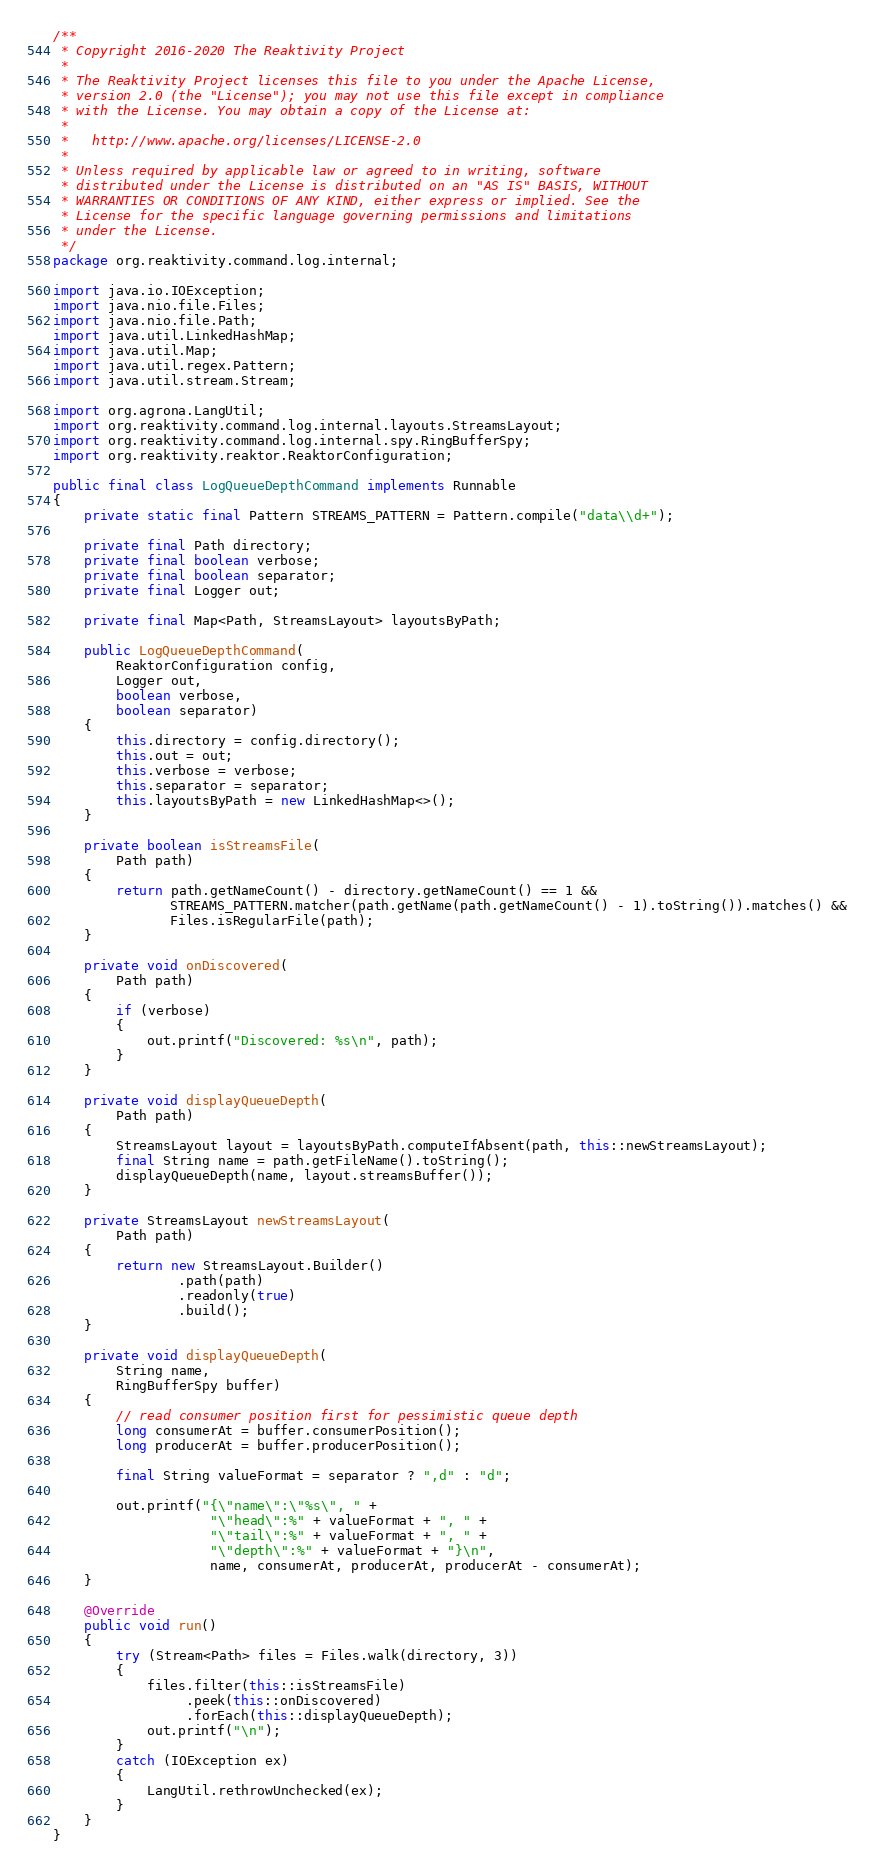Convert code to text. <code><loc_0><loc_0><loc_500><loc_500><_Java_>/**
 * Copyright 2016-2020 The Reaktivity Project
 *
 * The Reaktivity Project licenses this file to you under the Apache License,
 * version 2.0 (the "License"); you may not use this file except in compliance
 * with the License. You may obtain a copy of the License at:
 *
 *   http://www.apache.org/licenses/LICENSE-2.0
 *
 * Unless required by applicable law or agreed to in writing, software
 * distributed under the License is distributed on an "AS IS" BASIS, WITHOUT
 * WARRANTIES OR CONDITIONS OF ANY KIND, either express or implied. See the
 * License for the specific language governing permissions and limitations
 * under the License.
 */
package org.reaktivity.command.log.internal;

import java.io.IOException;
import java.nio.file.Files;
import java.nio.file.Path;
import java.util.LinkedHashMap;
import java.util.Map;
import java.util.regex.Pattern;
import java.util.stream.Stream;

import org.agrona.LangUtil;
import org.reaktivity.command.log.internal.layouts.StreamsLayout;
import org.reaktivity.command.log.internal.spy.RingBufferSpy;
import org.reaktivity.reaktor.ReaktorConfiguration;

public final class LogQueueDepthCommand implements Runnable
{
    private static final Pattern STREAMS_PATTERN = Pattern.compile("data\\d+");

    private final Path directory;
    private final boolean verbose;
    private final boolean separator;
    private final Logger out;

    private final Map<Path, StreamsLayout> layoutsByPath;

    public LogQueueDepthCommand(
        ReaktorConfiguration config,
        Logger out,
        boolean verbose,
        boolean separator)
    {
        this.directory = config.directory();
        this.out = out;
        this.verbose = verbose;
        this.separator = separator;
        this.layoutsByPath = new LinkedHashMap<>();
    }

    private boolean isStreamsFile(
        Path path)
    {
        return path.getNameCount() - directory.getNameCount() == 1 &&
               STREAMS_PATTERN.matcher(path.getName(path.getNameCount() - 1).toString()).matches() &&
               Files.isRegularFile(path);
    }

    private void onDiscovered(
        Path path)
    {
        if (verbose)
        {
            out.printf("Discovered: %s\n", path);
        }
    }

    private void displayQueueDepth(
        Path path)
    {
        StreamsLayout layout = layoutsByPath.computeIfAbsent(path, this::newStreamsLayout);
        final String name = path.getFileName().toString();
        displayQueueDepth(name, layout.streamsBuffer());
    }

    private StreamsLayout newStreamsLayout(
        Path path)
    {
        return new StreamsLayout.Builder()
                .path(path)
                .readonly(true)
                .build();
    }

    private void displayQueueDepth(
        String name,
        RingBufferSpy buffer)
    {
        // read consumer position first for pessimistic queue depth
        long consumerAt = buffer.consumerPosition();
        long producerAt = buffer.producerPosition();

        final String valueFormat = separator ? ",d" : "d";

        out.printf("{\"name\":\"%s\", " +
                    "\"head\":%" + valueFormat + ", " +
                    "\"tail\":%" + valueFormat + ", " +
                    "\"depth\":%" + valueFormat + "}\n",
                    name, consumerAt, producerAt, producerAt - consumerAt);
    }

    @Override
    public void run()
    {
        try (Stream<Path> files = Files.walk(directory, 3))
        {
            files.filter(this::isStreamsFile)
                 .peek(this::onDiscovered)
                 .forEach(this::displayQueueDepth);
            out.printf("\n");
        }
        catch (IOException ex)
        {
            LangUtil.rethrowUnchecked(ex);
        }
    }
}
</code> 